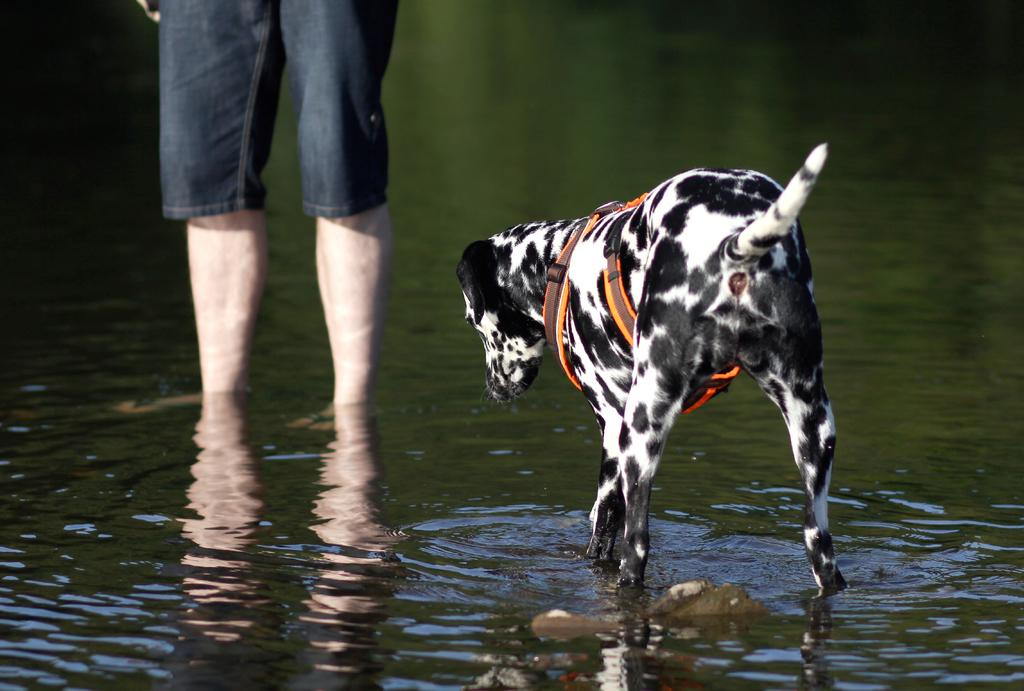What type of animal is in the image? There is a dalmatian dog in the image. Where is the dog located in the image? The dog is standing in the lake water. Can you see any human presence in the image? Yes, the legs of a person are visible in the image. How would you describe the background of the image? The background of the image is blurred. What type of fiction is the dog reading in the image? There is no fiction present in the image, as the dog is standing in the lake water and not reading anything. 